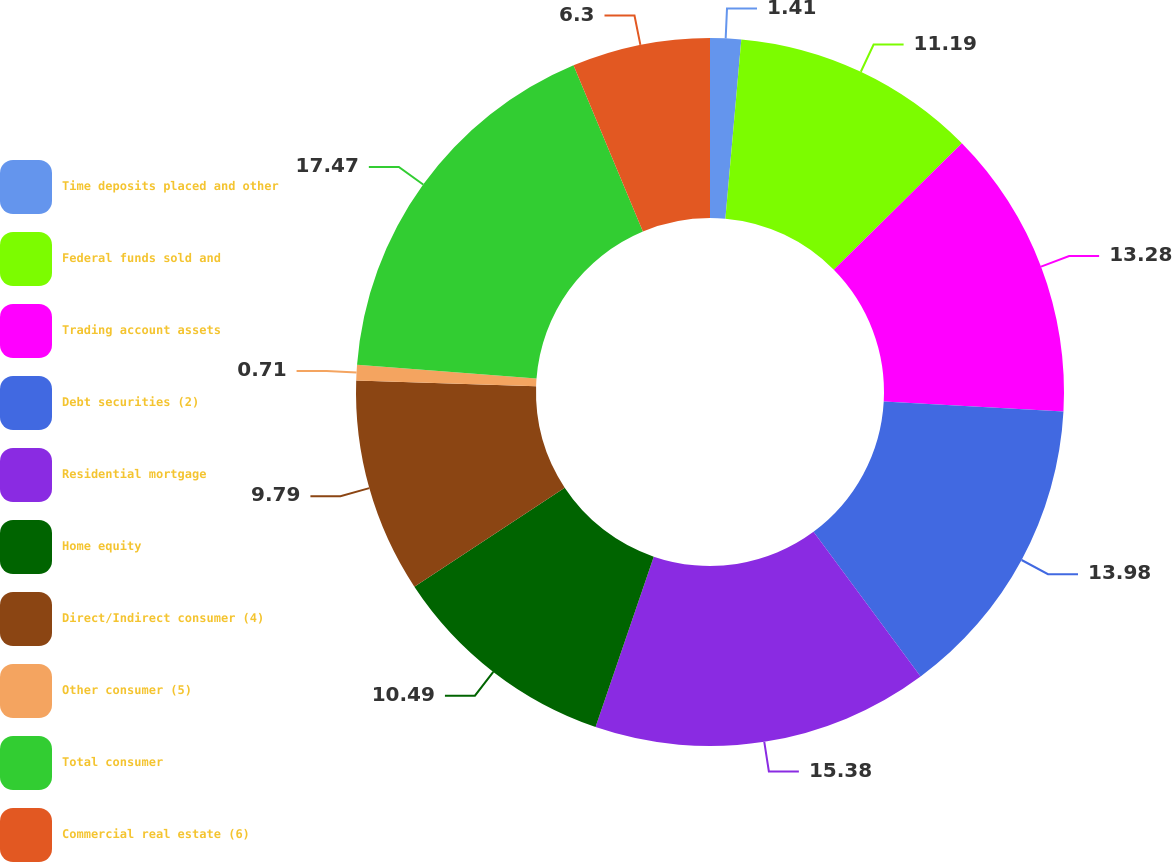Convert chart to OTSL. <chart><loc_0><loc_0><loc_500><loc_500><pie_chart><fcel>Time deposits placed and other<fcel>Federal funds sold and<fcel>Trading account assets<fcel>Debt securities (2)<fcel>Residential mortgage<fcel>Home equity<fcel>Direct/Indirect consumer (4)<fcel>Other consumer (5)<fcel>Total consumer<fcel>Commercial real estate (6)<nl><fcel>1.41%<fcel>11.19%<fcel>13.28%<fcel>13.98%<fcel>15.38%<fcel>10.49%<fcel>9.79%<fcel>0.71%<fcel>17.47%<fcel>6.3%<nl></chart> 